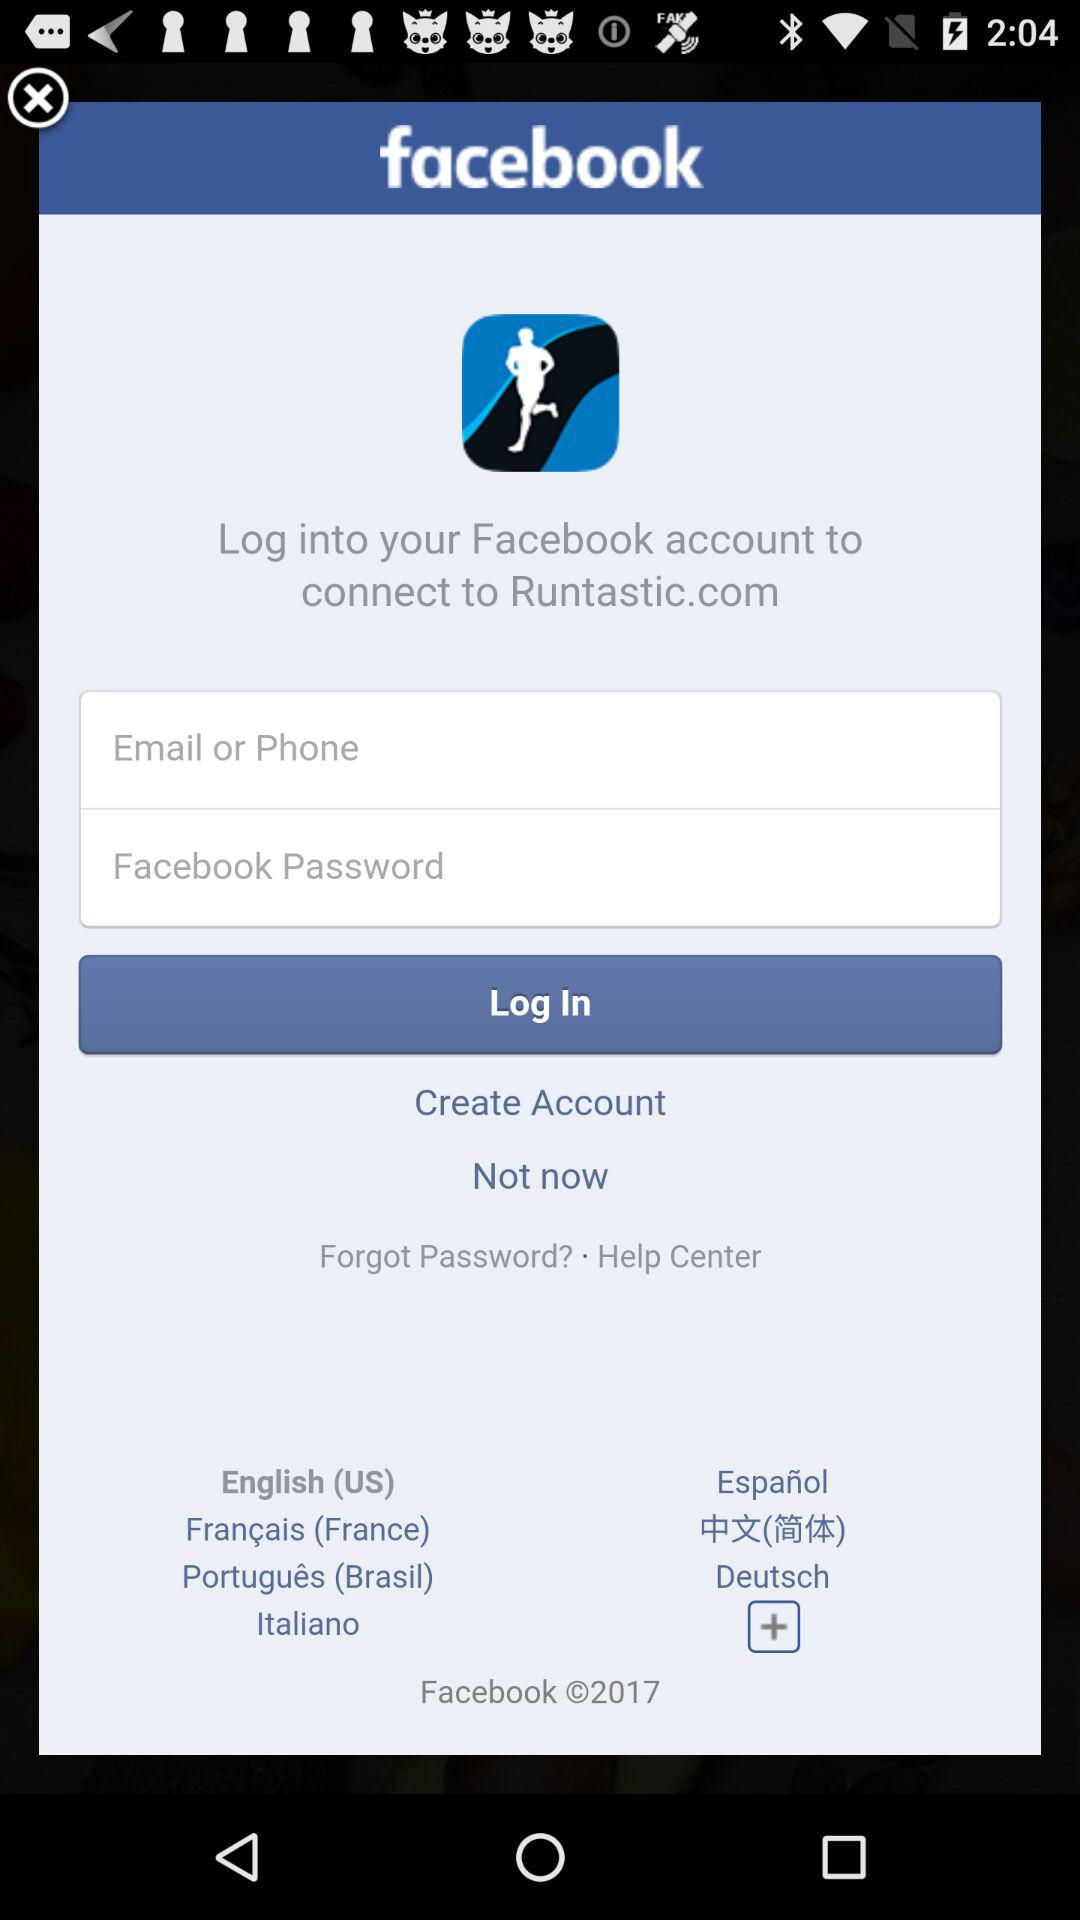Which language is selected? The selected language is English (US). 